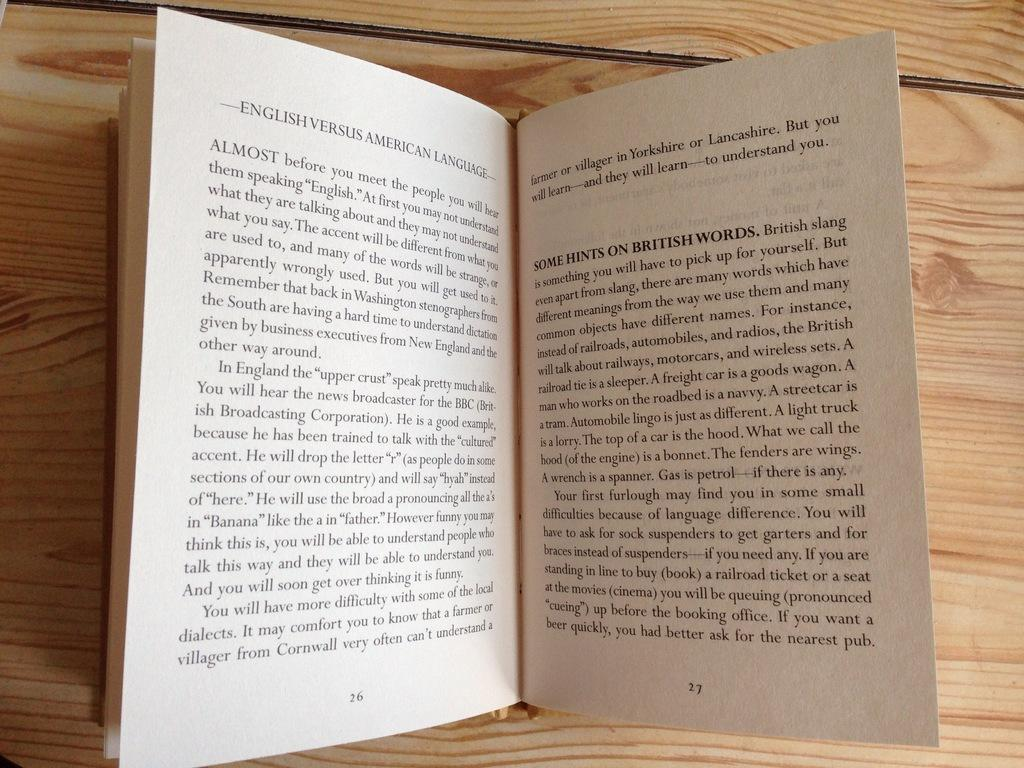<image>
Share a concise interpretation of the image provided. a page in a book about hints on British words 